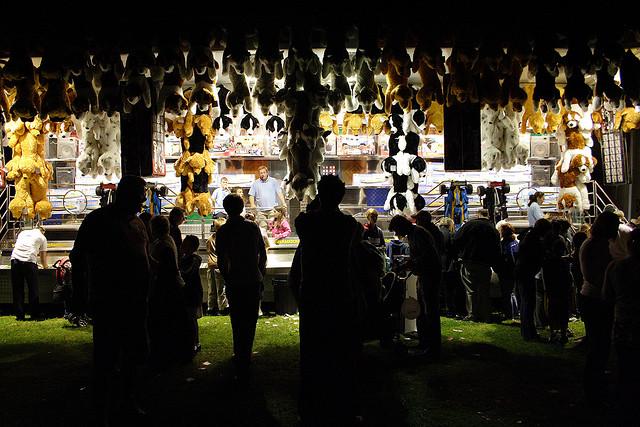Will people win prizes easily here?
Concise answer only. No. What is this place?
Give a very brief answer. Carnival. Is it day or night?
Short answer required. Night. 